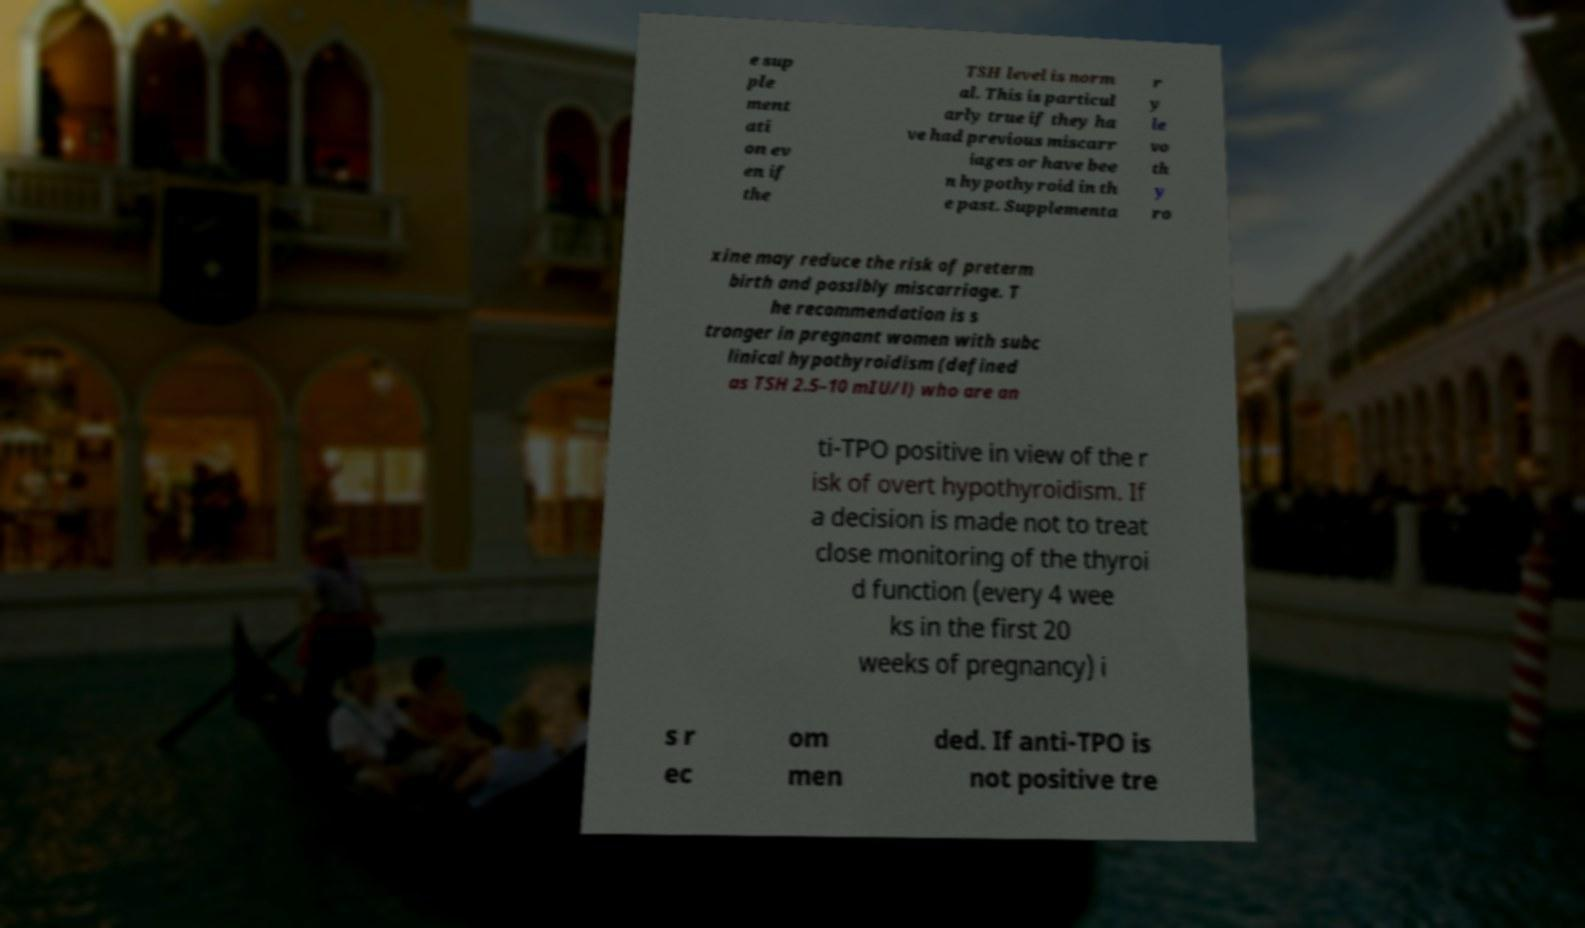Can you accurately transcribe the text from the provided image for me? e sup ple ment ati on ev en if the TSH level is norm al. This is particul arly true if they ha ve had previous miscarr iages or have bee n hypothyroid in th e past. Supplementa r y le vo th y ro xine may reduce the risk of preterm birth and possibly miscarriage. T he recommendation is s tronger in pregnant women with subc linical hypothyroidism (defined as TSH 2.5–10 mIU/l) who are an ti-TPO positive in view of the r isk of overt hypothyroidism. If a decision is made not to treat close monitoring of the thyroi d function (every 4 wee ks in the first 20 weeks of pregnancy) i s r ec om men ded. If anti-TPO is not positive tre 